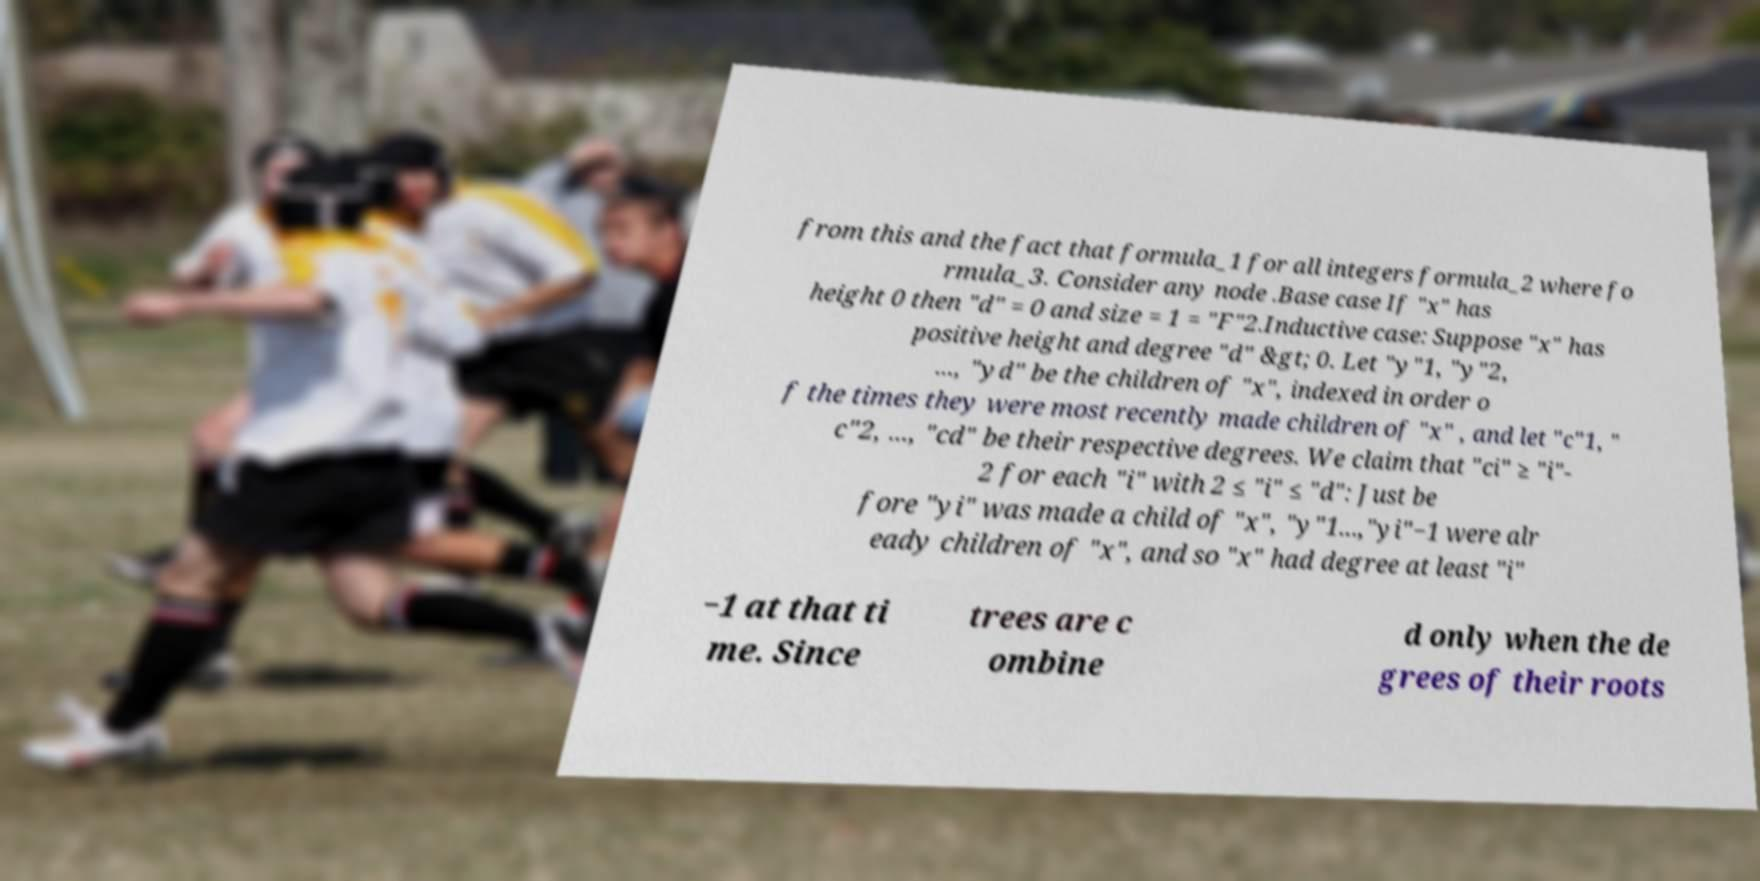For documentation purposes, I need the text within this image transcribed. Could you provide that? from this and the fact that formula_1 for all integers formula_2 where fo rmula_3. Consider any node .Base case If "x" has height 0 then "d" = 0 and size = 1 = "F"2.Inductive case: Suppose "x" has positive height and degree "d" &gt; 0. Let "y"1, "y"2, ..., "yd" be the children of "x", indexed in order o f the times they were most recently made children of "x" , and let "c"1, " c"2, ..., "cd" be their respective degrees. We claim that "ci" ≥ "i"- 2 for each "i" with 2 ≤ "i" ≤ "d": Just be fore "yi" was made a child of "x", "y"1...,"yi"−1 were alr eady children of "x", and so "x" had degree at least "i" −1 at that ti me. Since trees are c ombine d only when the de grees of their roots 